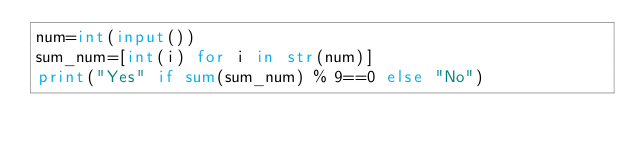Convert code to text. <code><loc_0><loc_0><loc_500><loc_500><_Python_>num=int(input())
sum_num=[int(i) for i in str(num)]
print("Yes" if sum(sum_num) % 9==0 else "No")</code> 